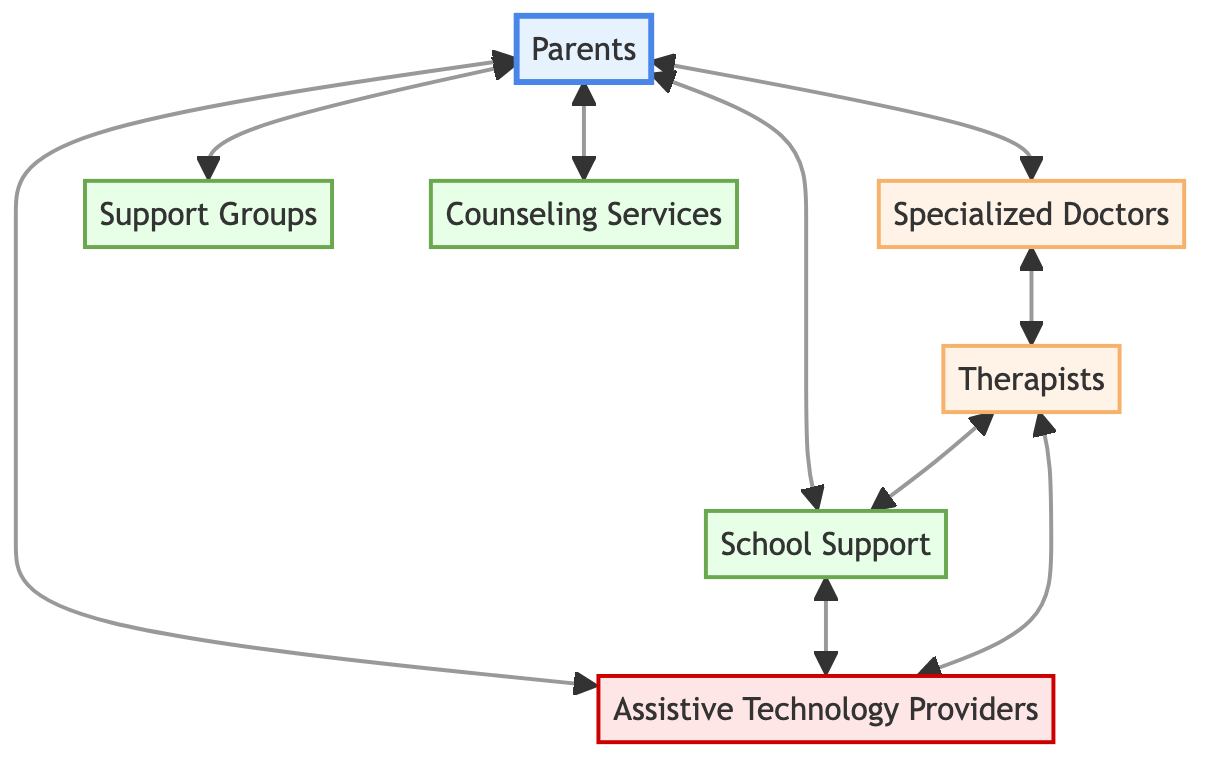What's the total number of components in the diagram? The diagram lists seven distinct components: Parents, Specialized Doctors, Therapists, School Support, Support Groups, Counseling Services, and Assistive Technology Providers.
Answer: Seven Which component connects directly to Parents? From the diagram, the nodes that connect to Parents are Specialized Doctors, School Support, Support Groups, Counseling Services, and Assistive Technology Providers.
Answer: Five What type of professionals are listed under Specialized Doctors? The components classified as Specialized Doctors include ophthalmologists and neurologists.
Answer: Ophthalmologists and neurologists How many connections are there for School Support? School Support connects to three components: Parents, Therapists, and Assistive Technology Providers. Thus, it has three connections.
Answer: Three Which component provides mobility assistance? Therapists are responsible for aiding in mobility skills as indicated in their description.
Answer: Therapists What is the flow of assistance from Parents to Support Groups? Assistance flows from Parents to Support Groups directly, indicating that Parents communicate or interact with Support Groups for emotional support.
Answer: Direct connection Which professional connects both therapy and education? Therapists connect both Specialized Doctors and School Support, indicating their role across the medical and educational systems.
Answer: Therapists What kind of community do Support Groups represent? Support Groups are described as local and online communities, which offer emotional support and resources.
Answer: Emotional support and resources How do Assistive Technology Providers support Parents? Assistive Technology Providers supply devices and software that assist visually impaired individuals, which directly benefits the support Parents seek for their children.
Answer: By providing devices and software 